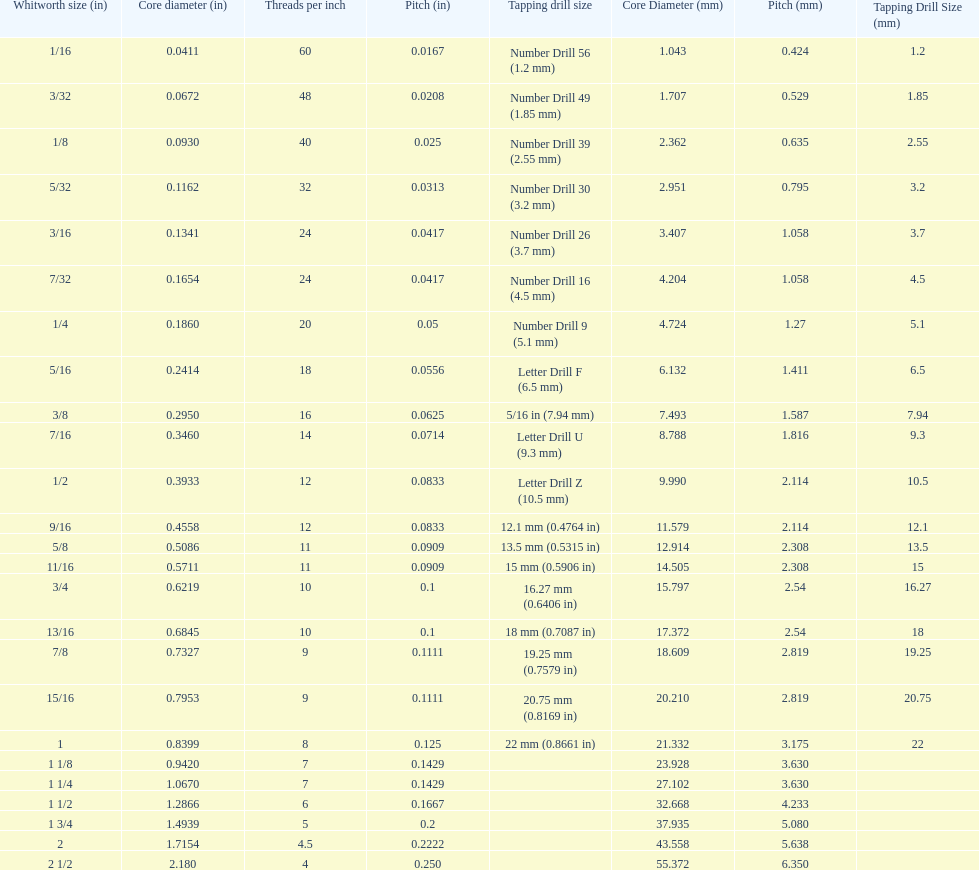How many more threads per inch does the 1/16th whitworth size have over the 1/8th whitworth size? 20. 